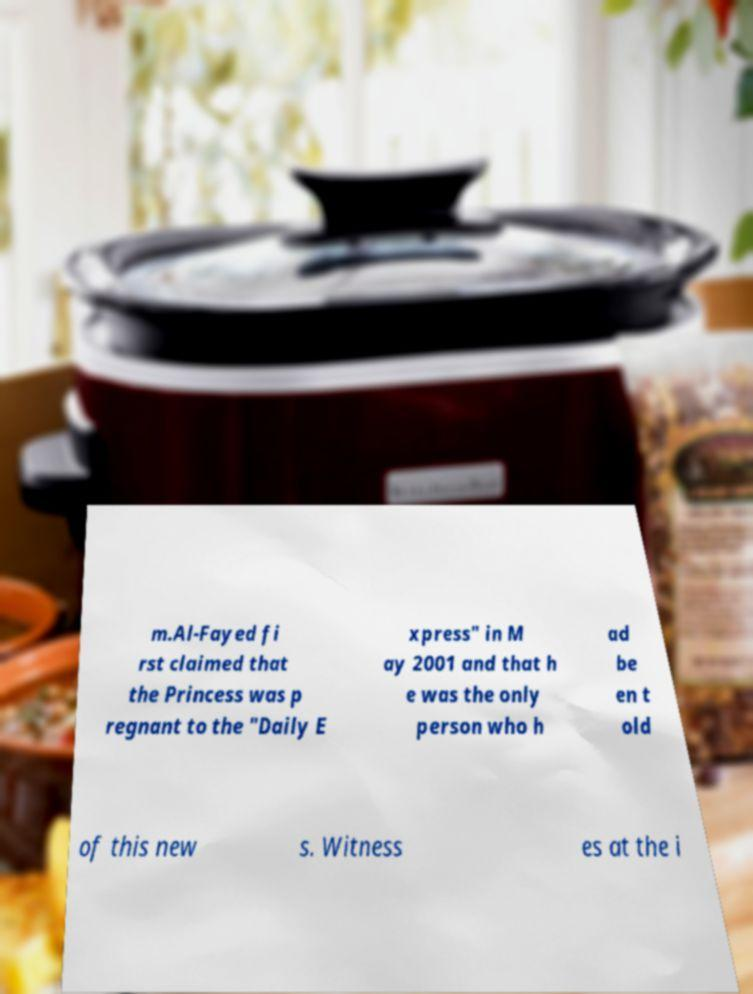Can you accurately transcribe the text from the provided image for me? m.Al-Fayed fi rst claimed that the Princess was p regnant to the "Daily E xpress" in M ay 2001 and that h e was the only person who h ad be en t old of this new s. Witness es at the i 